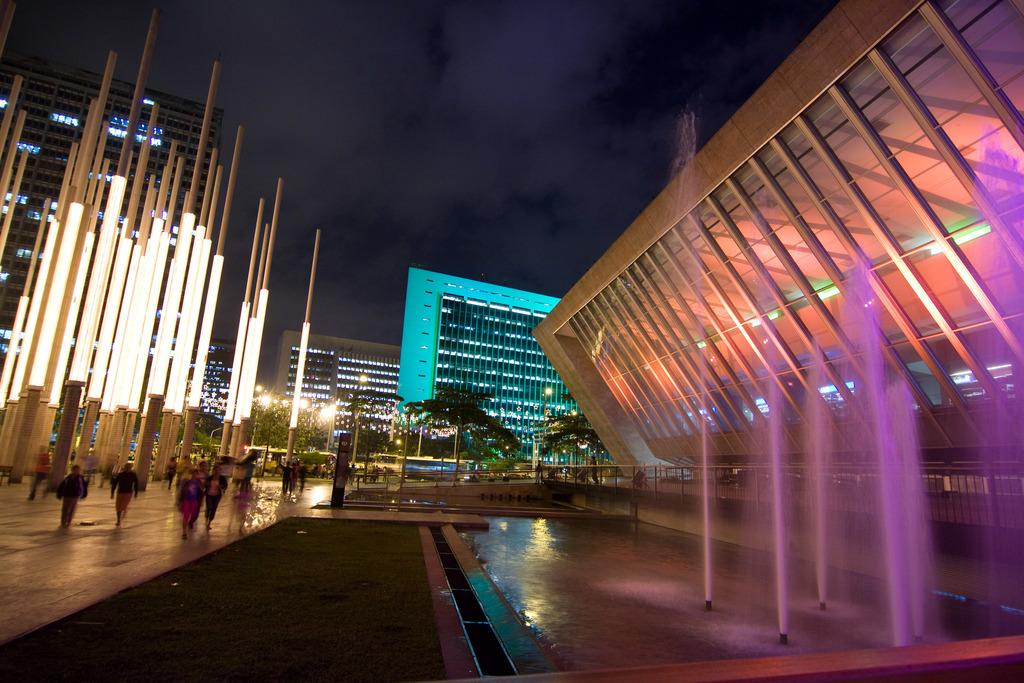What is happening at the left side of the image? There are people walking at the left side of the image. What can be seen at the right side of the image? There are water fountains at the right side of the image. What type of structures are visible in the image? There are buildings visible in the image. What is visible at the top of the image? The sky is visible at the top of the image. What type of ship can be seen sailing in the water fountain at the right side of the image? There is no ship present in the image; it features water fountains and people walking. What type of crack is visible on the buildings in the image? There is no crack visible on the buildings in the image; the buildings appear to be in good condition. 